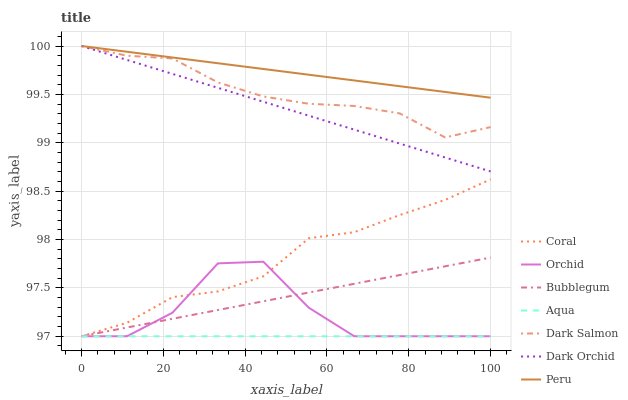Does Aqua have the minimum area under the curve?
Answer yes or no. Yes. Does Peru have the maximum area under the curve?
Answer yes or no. Yes. Does Dark Salmon have the minimum area under the curve?
Answer yes or no. No. Does Dark Salmon have the maximum area under the curve?
Answer yes or no. No. Is Aqua the smoothest?
Answer yes or no. Yes. Is Orchid the roughest?
Answer yes or no. Yes. Is Dark Salmon the smoothest?
Answer yes or no. No. Is Dark Salmon the roughest?
Answer yes or no. No. Does Coral have the lowest value?
Answer yes or no. Yes. Does Dark Salmon have the lowest value?
Answer yes or no. No. Does Peru have the highest value?
Answer yes or no. Yes. Does Aqua have the highest value?
Answer yes or no. No. Is Coral less than Peru?
Answer yes or no. Yes. Is Dark Salmon greater than Orchid?
Answer yes or no. Yes. Does Coral intersect Orchid?
Answer yes or no. Yes. Is Coral less than Orchid?
Answer yes or no. No. Is Coral greater than Orchid?
Answer yes or no. No. Does Coral intersect Peru?
Answer yes or no. No. 